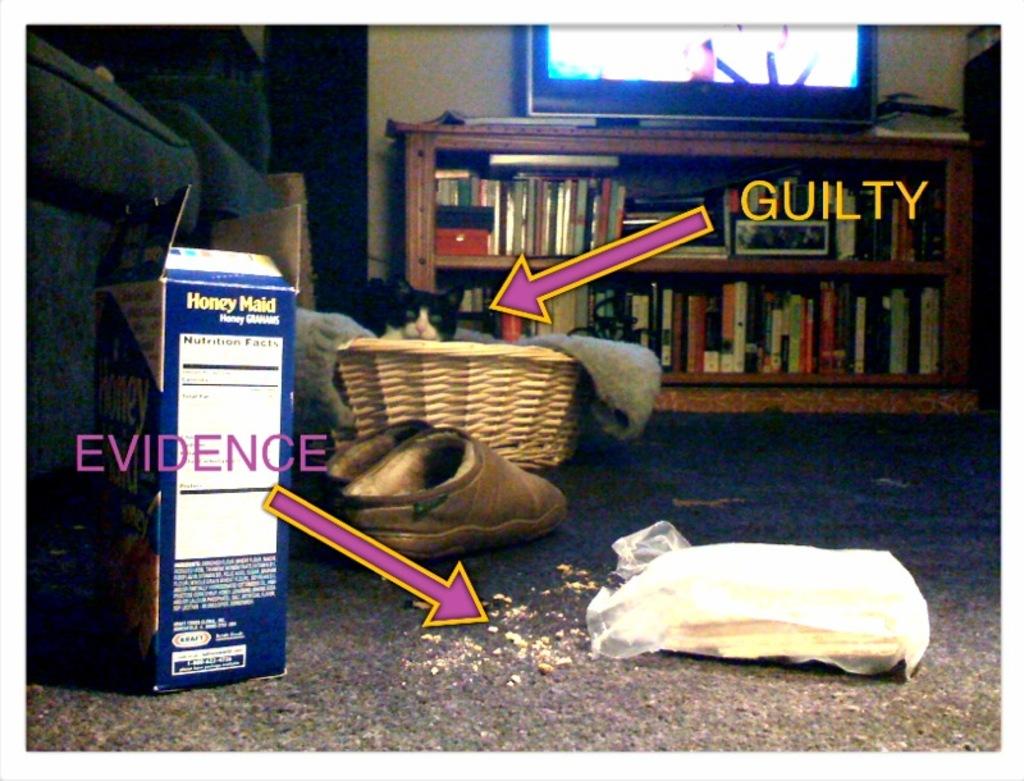What is in the box?
Offer a terse response. Honey maid. 